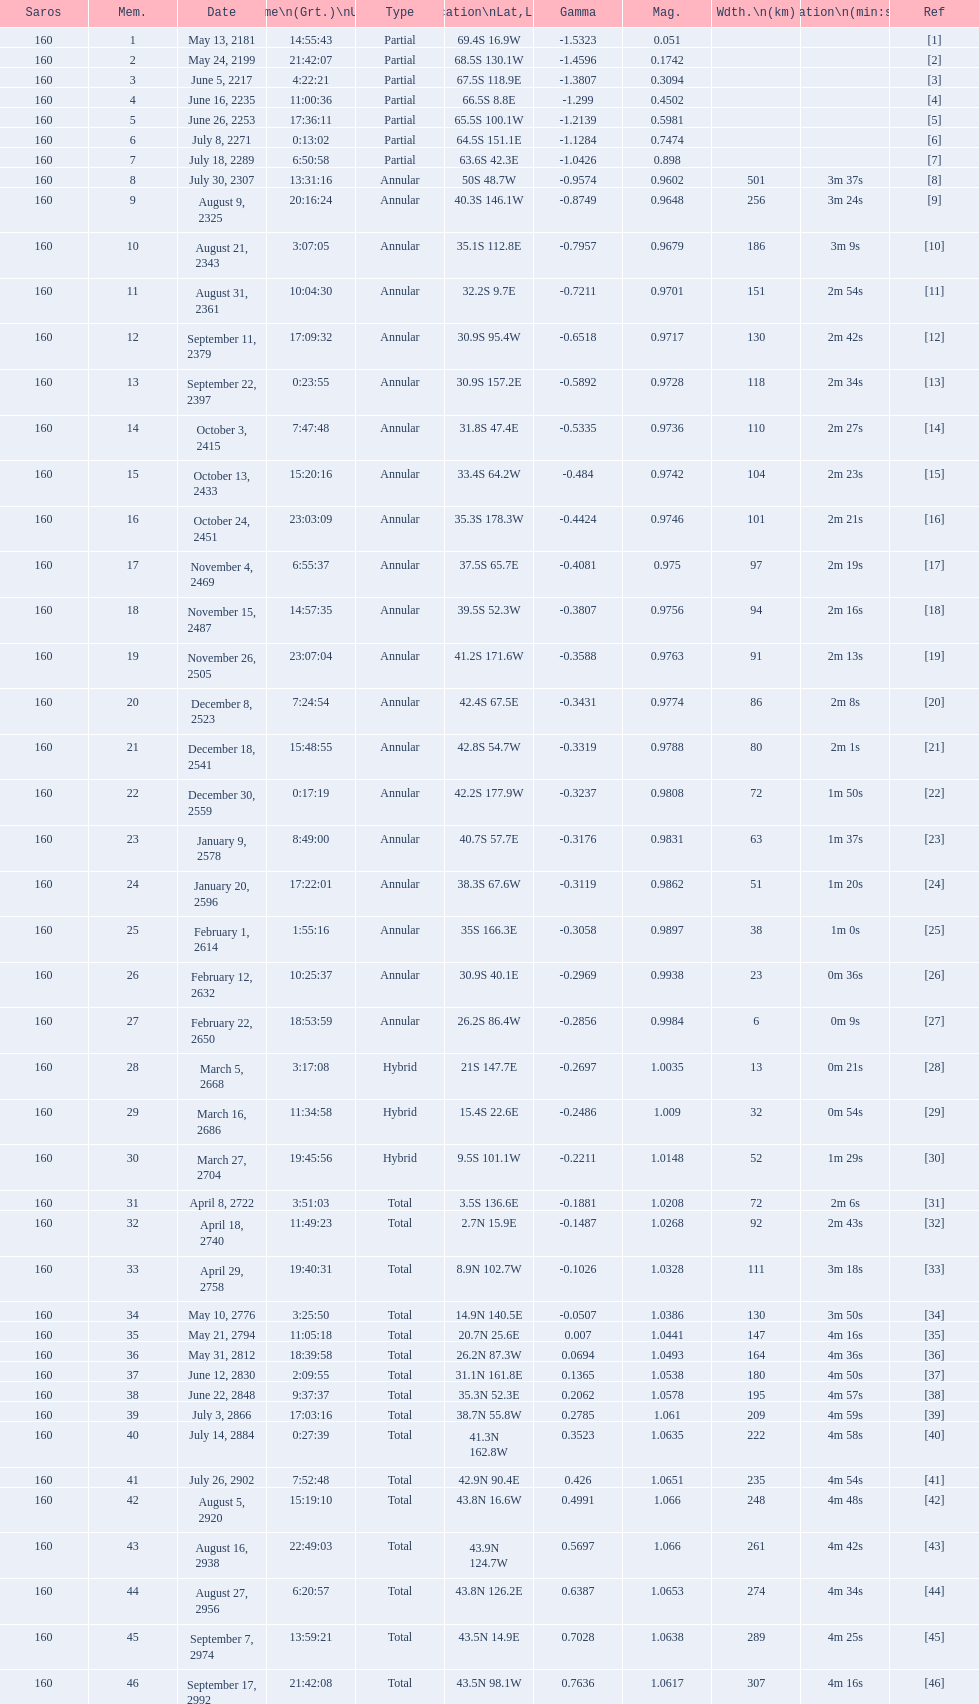Name one that has the same latitude as member number 12. 13. 